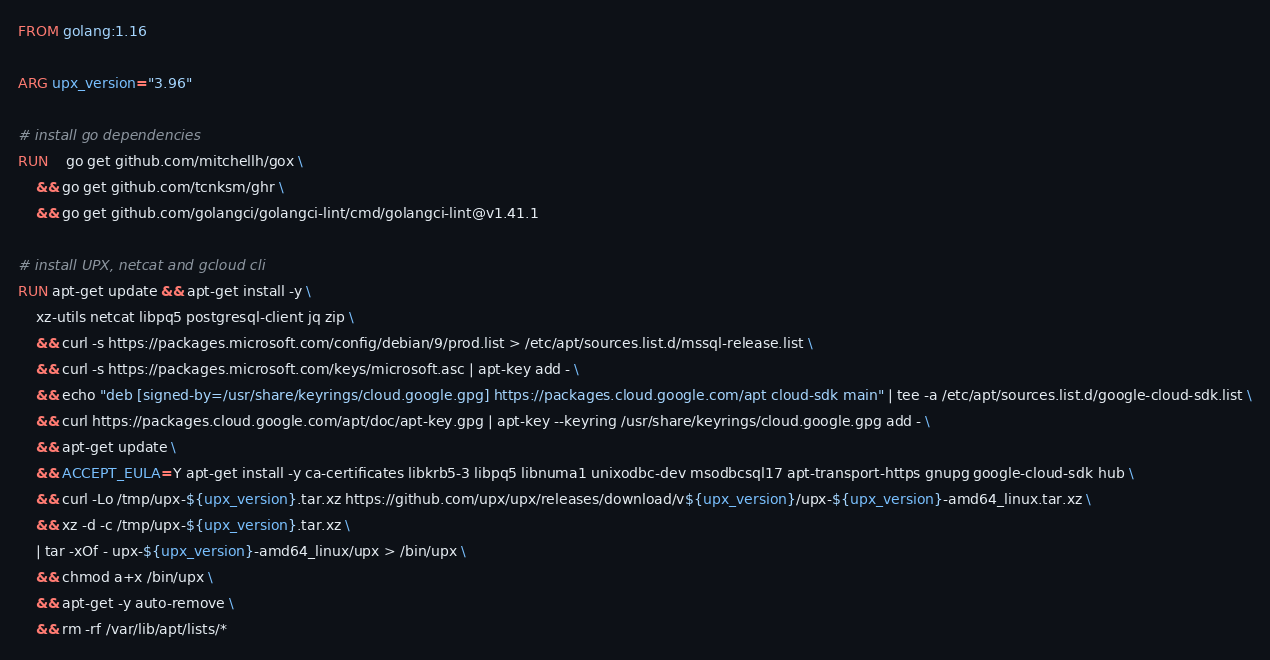<code> <loc_0><loc_0><loc_500><loc_500><_Dockerfile_>FROM golang:1.16

ARG upx_version="3.96"

# install go dependencies
RUN	go get github.com/mitchellh/gox \
    && go get github.com/tcnksm/ghr \
    && go get github.com/golangci/golangci-lint/cmd/golangci-lint@v1.41.1

# install UPX, netcat and gcloud cli
RUN apt-get update && apt-get install -y \
    xz-utils netcat libpq5 postgresql-client jq zip \
    && curl -s https://packages.microsoft.com/config/debian/9/prod.list > /etc/apt/sources.list.d/mssql-release.list \
    && curl -s https://packages.microsoft.com/keys/microsoft.asc | apt-key add - \
    && echo "deb [signed-by=/usr/share/keyrings/cloud.google.gpg] https://packages.cloud.google.com/apt cloud-sdk main" | tee -a /etc/apt/sources.list.d/google-cloud-sdk.list \
    && curl https://packages.cloud.google.com/apt/doc/apt-key.gpg | apt-key --keyring /usr/share/keyrings/cloud.google.gpg add - \
    && apt-get update \
    && ACCEPT_EULA=Y apt-get install -y ca-certificates libkrb5-3 libpq5 libnuma1 unixodbc-dev msodbcsql17 apt-transport-https gnupg google-cloud-sdk hub \
    && curl -Lo /tmp/upx-${upx_version}.tar.xz https://github.com/upx/upx/releases/download/v${upx_version}/upx-${upx_version}-amd64_linux.tar.xz \
    && xz -d -c /tmp/upx-${upx_version}.tar.xz \
    | tar -xOf - upx-${upx_version}-amd64_linux/upx > /bin/upx \
    && chmod a+x /bin/upx \
    && apt-get -y auto-remove \
    && rm -rf /var/lib/apt/lists/*
</code> 